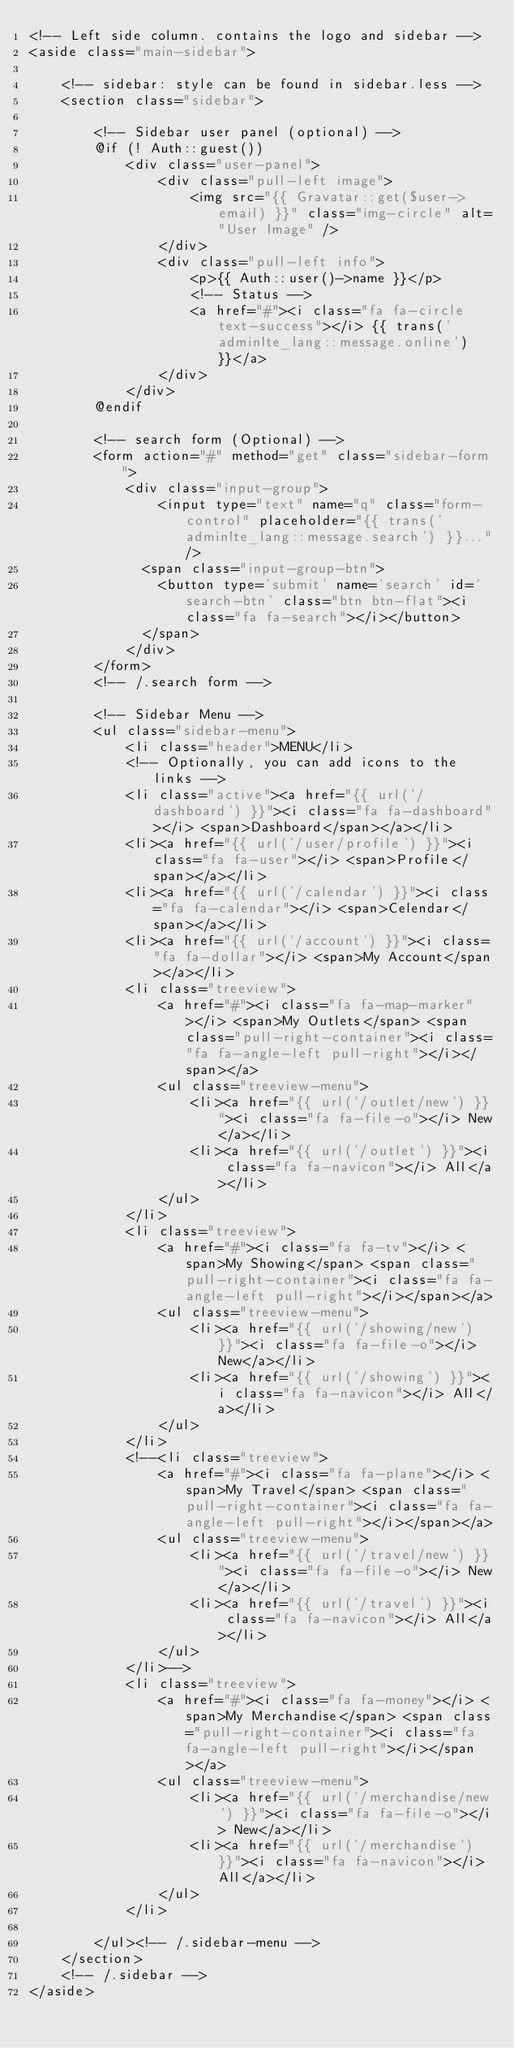<code> <loc_0><loc_0><loc_500><loc_500><_PHP_><!-- Left side column. contains the logo and sidebar -->
<aside class="main-sidebar">

    <!-- sidebar: style can be found in sidebar.less -->
    <section class="sidebar">

        <!-- Sidebar user panel (optional) -->
        @if (! Auth::guest())
            <div class="user-panel">
                <div class="pull-left image">
                    <img src="{{ Gravatar::get($user->email) }}" class="img-circle" alt="User Image" />
                </div>
                <div class="pull-left info">
                    <p>{{ Auth::user()->name }}</p>
                    <!-- Status -->
                    <a href="#"><i class="fa fa-circle text-success"></i> {{ trans('adminlte_lang::message.online') }}</a>
                </div>
            </div>
        @endif

        <!-- search form (Optional) -->
        <form action="#" method="get" class="sidebar-form">
            <div class="input-group">
                <input type="text" name="q" class="form-control" placeholder="{{ trans('adminlte_lang::message.search') }}..."/>
              <span class="input-group-btn">
                <button type='submit' name='search' id='search-btn' class="btn btn-flat"><i class="fa fa-search"></i></button>
              </span>
            </div>
        </form>
        <!-- /.search form -->

        <!-- Sidebar Menu -->
        <ul class="sidebar-menu">
            <li class="header">MENU</li>
            <!-- Optionally, you can add icons to the links -->
            <li class="active"><a href="{{ url('/dashboard') }}"><i class="fa fa-dashboard"></i> <span>Dashboard</span></a></li>
            <li><a href="{{ url('/user/profile') }}"><i class="fa fa-user"></i> <span>Profile</span></a></li>
            <li><a href="{{ url('/calendar') }}"><i class="fa fa-calendar"></i> <span>Celendar</span></a></li>
            <li><a href="{{ url('/account') }}"><i class="fa fa-dollar"></i> <span>My Account</span></a></li>
            <li class="treeview">
                <a href="#"><i class="fa fa-map-marker"></i> <span>My Outlets</span> <span class="pull-right-container"><i class="fa fa-angle-left pull-right"></i></span></a>
                <ul class="treeview-menu">
                    <li><a href="{{ url('/outlet/new') }}"><i class="fa fa-file-o"></i> New</a></li>
                    <li><a href="{{ url('/outlet') }}"><i class="fa fa-navicon"></i> All</a></li>
                </ul>
            </li>
            <li class="treeview">
                <a href="#"><i class="fa fa-tv"></i> <span>My Showing</span> <span class="pull-right-container"><i class="fa fa-angle-left pull-right"></i></span></a>
                <ul class="treeview-menu">
                    <li><a href="{{ url('/showing/new') }}"><i class="fa fa-file-o"></i> New</a></li>
                    <li><a href="{{ url('/showing') }}"><i class="fa fa-navicon"></i> All</a></li>
                </ul>
            </li>
            <!--<li class="treeview">
                <a href="#"><i class="fa fa-plane"></i> <span>My Travel</span> <span class="pull-right-container"><i class="fa fa-angle-left pull-right"></i></span></a>
                <ul class="treeview-menu">
                    <li><a href="{{ url('/travel/new') }}"><i class="fa fa-file-o"></i> New</a></li>
                    <li><a href="{{ url('/travel') }}"><i class="fa fa-navicon"></i> All</a></li>
                </ul>
            </li>-->
            <li class="treeview">
                <a href="#"><i class="fa fa-money"></i> <span>My Merchandise</span> <span class="pull-right-container"><i class="fa fa-angle-left pull-right"></i></span></a>
                <ul class="treeview-menu">
                    <li><a href="{{ url('/merchandise/new') }}"><i class="fa fa-file-o"></i> New</a></li>
                    <li><a href="{{ url('/merchandise') }}"><i class="fa fa-navicon"></i> All</a></li>
                </ul>
            </li>

        </ul><!-- /.sidebar-menu -->
    </section>
    <!-- /.sidebar -->
</aside>
</code> 